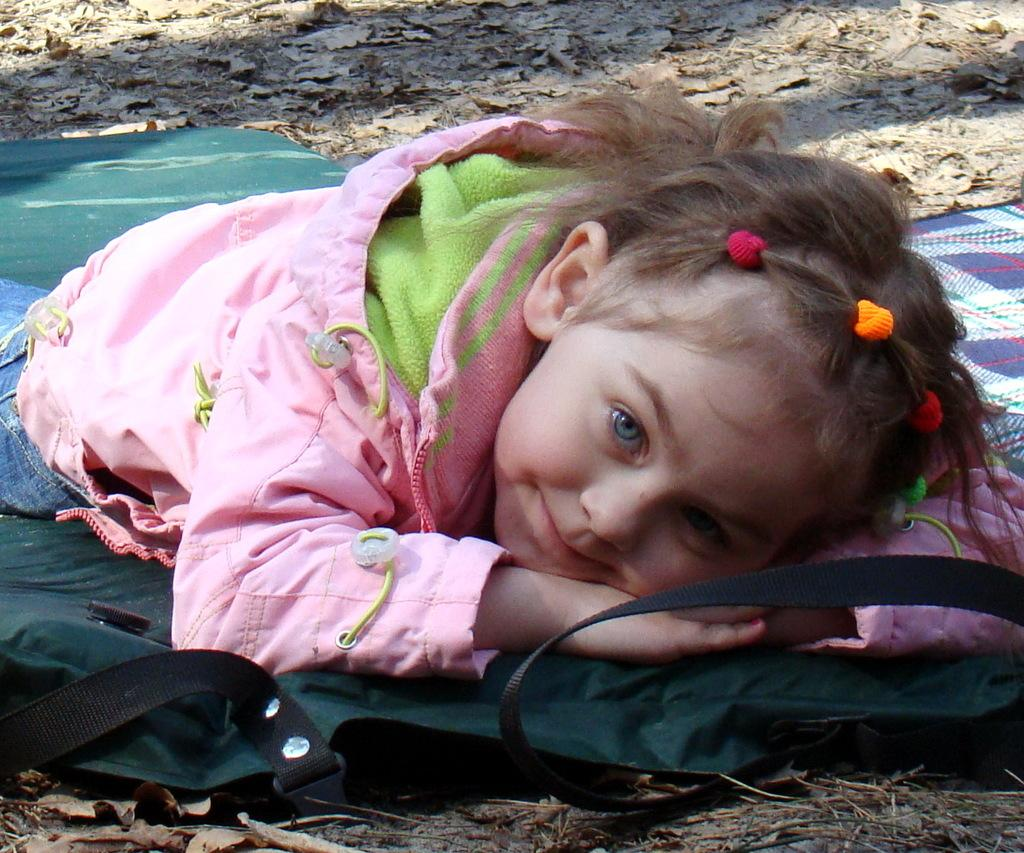What is on the ground in the image? There are clothes, dried leaves, and sticks on the ground in the image. What is the girl in the image doing? The girl is smiling in the image. Can you describe the girl's expression? The girl is smiling in the image. What type of plant is the girl using to dig in the image? There is no plant or digging activity present in the image. What does the girl need to complete her task in the image? The image does not show any tasks being performed by the girl, so it is not possible to determine what she might need. 